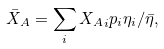<formula> <loc_0><loc_0><loc_500><loc_500>\bar { X } _ { A } = \sum _ { i } { X _ { A } } _ { i } p _ { i } \eta _ { i } / \bar { \eta } ,</formula> 